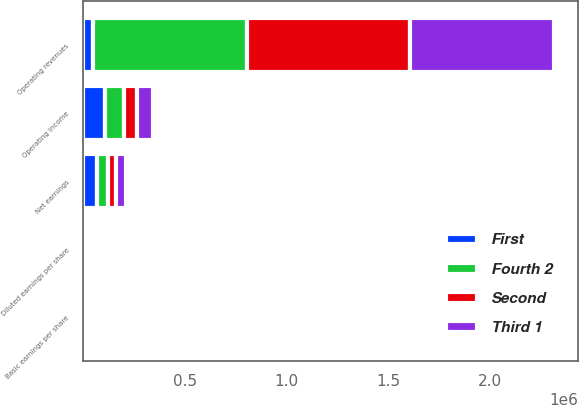Convert chart to OTSL. <chart><loc_0><loc_0><loc_500><loc_500><stacked_bar_chart><ecel><fcel>Operating revenues<fcel>Operating income<fcel>Net earnings<fcel>Basic earnings per share<fcel>Diluted earnings per share<nl><fcel>Third 1<fcel>709178<fcel>79167<fcel>47499<fcel>0.3<fcel>0.29<nl><fcel>Fourth 2<fcel>759206<fcel>93005<fcel>54631<fcel>0.34<fcel>0.33<nl><fcel>Second<fcel>801140<fcel>65102<fcel>39843<fcel>0.25<fcel>0.25<nl><fcel>First<fcel>47499<fcel>106626<fcel>65338<fcel>0.42<fcel>0.41<nl></chart> 